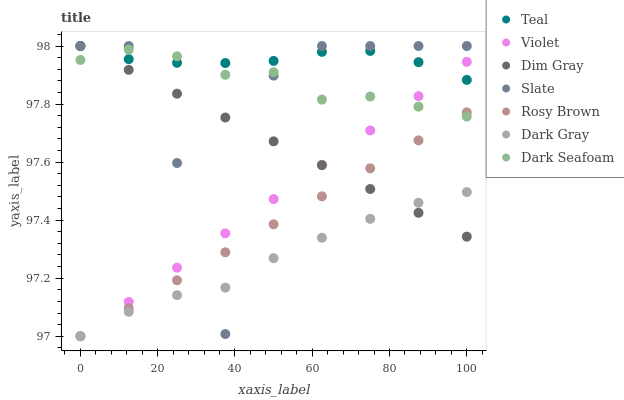Does Dark Gray have the minimum area under the curve?
Answer yes or no. Yes. Does Teal have the maximum area under the curve?
Answer yes or no. Yes. Does Slate have the minimum area under the curve?
Answer yes or no. No. Does Slate have the maximum area under the curve?
Answer yes or no. No. Is Violet the smoothest?
Answer yes or no. Yes. Is Slate the roughest?
Answer yes or no. Yes. Is Rosy Brown the smoothest?
Answer yes or no. No. Is Rosy Brown the roughest?
Answer yes or no. No. Does Rosy Brown have the lowest value?
Answer yes or no. Yes. Does Slate have the lowest value?
Answer yes or no. No. Does Teal have the highest value?
Answer yes or no. Yes. Does Rosy Brown have the highest value?
Answer yes or no. No. Is Rosy Brown less than Teal?
Answer yes or no. Yes. Is Teal greater than Dark Gray?
Answer yes or no. Yes. Does Slate intersect Teal?
Answer yes or no. Yes. Is Slate less than Teal?
Answer yes or no. No. Is Slate greater than Teal?
Answer yes or no. No. Does Rosy Brown intersect Teal?
Answer yes or no. No. 